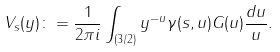<formula> <loc_0><loc_0><loc_500><loc_500>V _ { s } ( y ) \colon = \frac { 1 } { 2 \pi i } \int _ { ( 3 / 2 ) } y ^ { - u } \gamma ( s , u ) G ( u ) \frac { d u } { u } .</formula> 